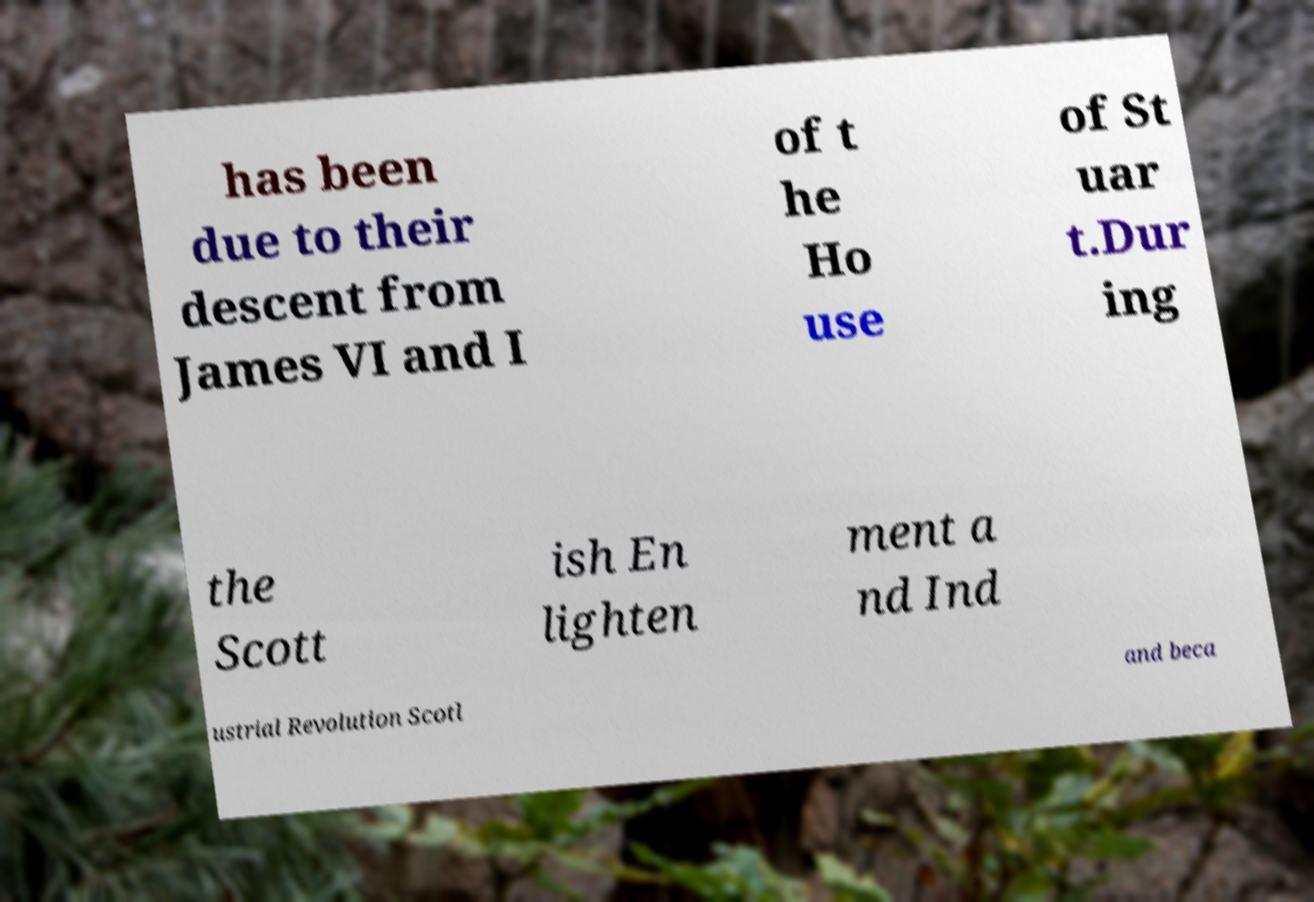I need the written content from this picture converted into text. Can you do that? has been due to their descent from James VI and I of t he Ho use of St uar t.Dur ing the Scott ish En lighten ment a nd Ind ustrial Revolution Scotl and beca 